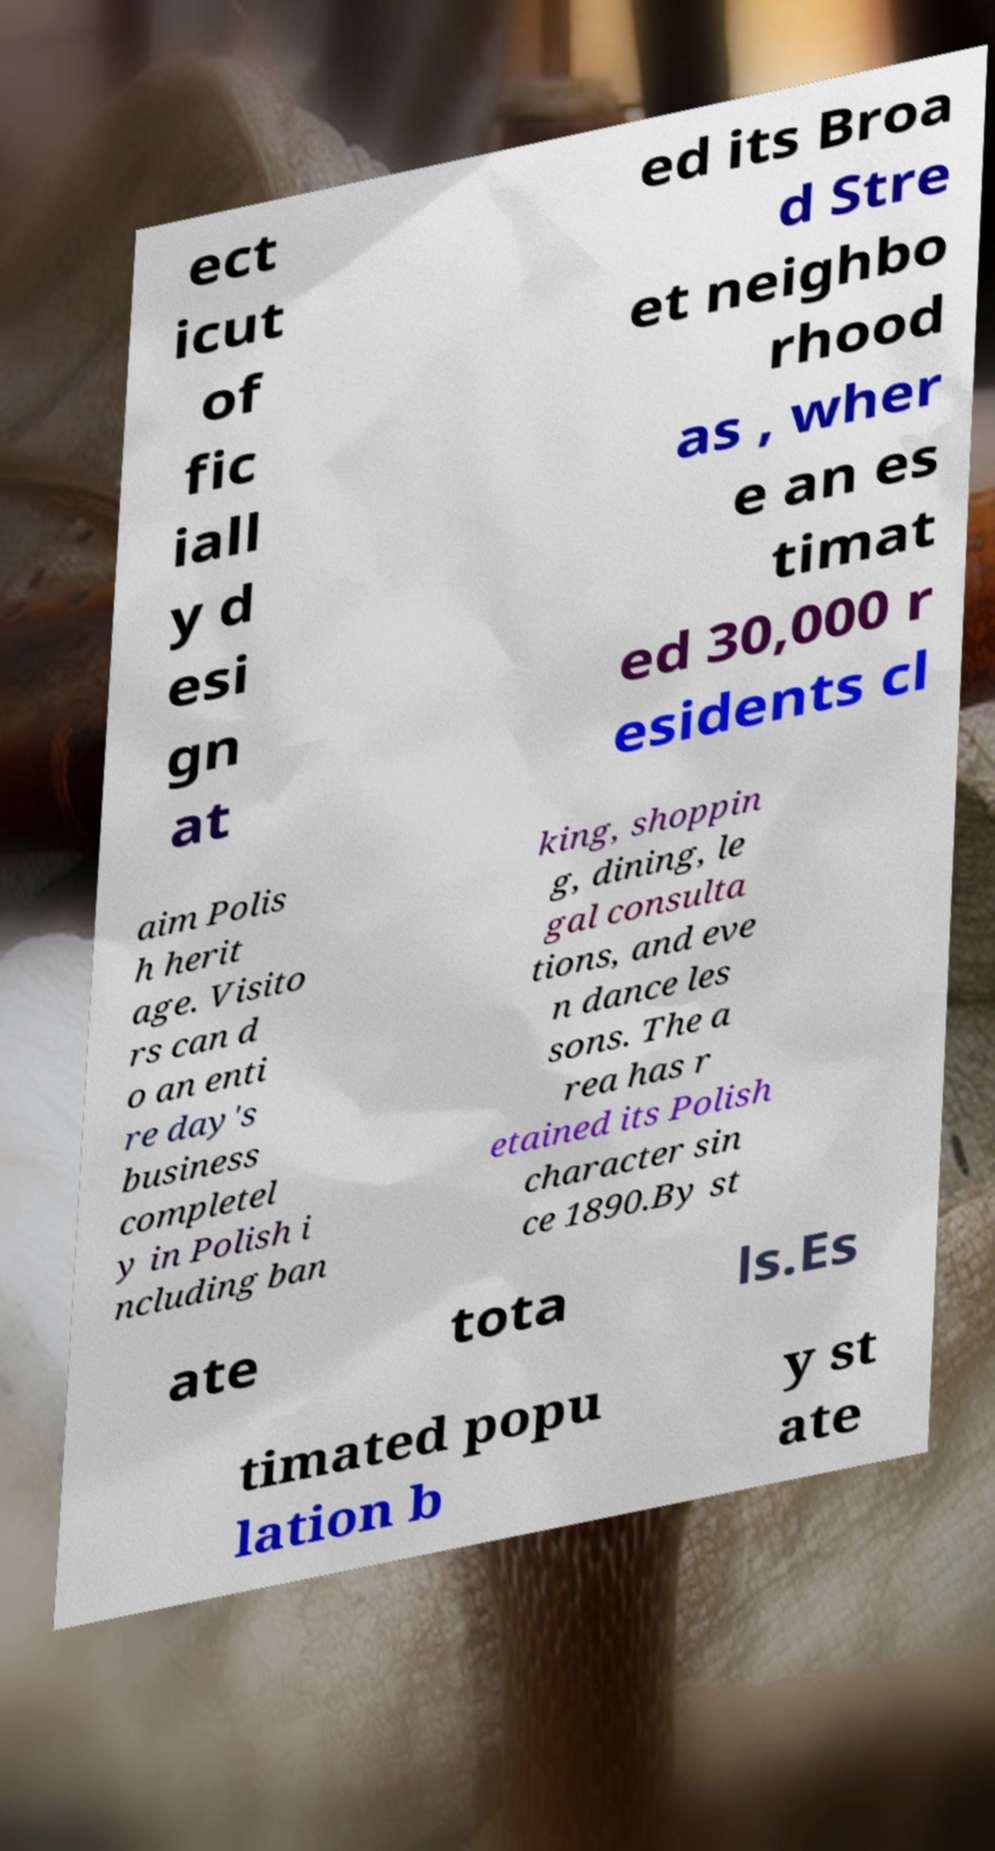There's text embedded in this image that I need extracted. Can you transcribe it verbatim? ect icut of fic iall y d esi gn at ed its Broa d Stre et neighbo rhood as , wher e an es timat ed 30,000 r esidents cl aim Polis h herit age. Visito rs can d o an enti re day's business completel y in Polish i ncluding ban king, shoppin g, dining, le gal consulta tions, and eve n dance les sons. The a rea has r etained its Polish character sin ce 1890.By st ate tota ls.Es timated popu lation b y st ate 